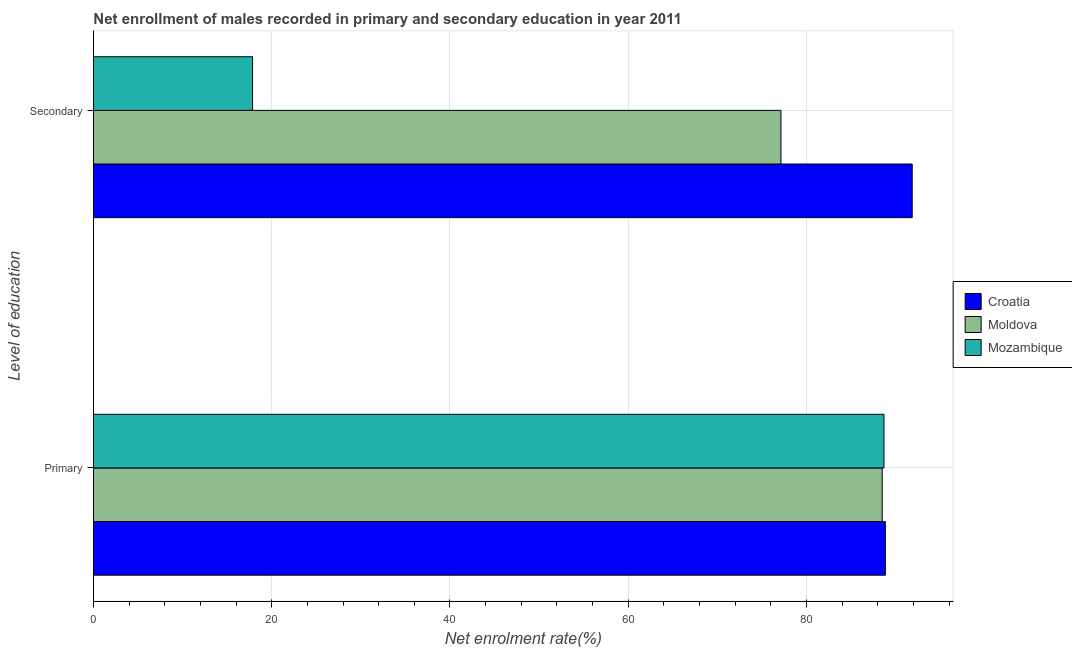How many bars are there on the 2nd tick from the bottom?
Ensure brevity in your answer.  3. What is the label of the 2nd group of bars from the top?
Your answer should be very brief. Primary. What is the enrollment rate in primary education in Moldova?
Make the answer very short. 88.49. Across all countries, what is the maximum enrollment rate in secondary education?
Make the answer very short. 91.86. Across all countries, what is the minimum enrollment rate in primary education?
Offer a terse response. 88.49. In which country was the enrollment rate in secondary education maximum?
Provide a succinct answer. Croatia. In which country was the enrollment rate in secondary education minimum?
Keep it short and to the point. Mozambique. What is the total enrollment rate in primary education in the graph?
Offer a terse response. 266.03. What is the difference between the enrollment rate in secondary education in Moldova and that in Croatia?
Provide a short and direct response. -14.73. What is the difference between the enrollment rate in secondary education in Croatia and the enrollment rate in primary education in Mozambique?
Provide a short and direct response. 3.17. What is the average enrollment rate in primary education per country?
Provide a succinct answer. 88.68. What is the difference between the enrollment rate in secondary education and enrollment rate in primary education in Moldova?
Provide a succinct answer. -11.36. In how many countries, is the enrollment rate in primary education greater than 68 %?
Your response must be concise. 3. What is the ratio of the enrollment rate in primary education in Moldova to that in Croatia?
Ensure brevity in your answer.  1. In how many countries, is the enrollment rate in secondary education greater than the average enrollment rate in secondary education taken over all countries?
Offer a very short reply. 2. What does the 3rd bar from the top in Secondary represents?
Offer a terse response. Croatia. What does the 1st bar from the bottom in Primary represents?
Ensure brevity in your answer.  Croatia. How many countries are there in the graph?
Give a very brief answer. 3. What is the difference between two consecutive major ticks on the X-axis?
Your answer should be very brief. 20. Are the values on the major ticks of X-axis written in scientific E-notation?
Keep it short and to the point. No. Does the graph contain any zero values?
Offer a terse response. No. Does the graph contain grids?
Give a very brief answer. Yes. Where does the legend appear in the graph?
Your answer should be compact. Center right. What is the title of the graph?
Provide a succinct answer. Net enrollment of males recorded in primary and secondary education in year 2011. What is the label or title of the X-axis?
Provide a short and direct response. Net enrolment rate(%). What is the label or title of the Y-axis?
Give a very brief answer. Level of education. What is the Net enrolment rate(%) in Croatia in Primary?
Offer a very short reply. 88.85. What is the Net enrolment rate(%) of Moldova in Primary?
Offer a very short reply. 88.49. What is the Net enrolment rate(%) in Mozambique in Primary?
Offer a very short reply. 88.69. What is the Net enrolment rate(%) of Croatia in Secondary?
Your answer should be very brief. 91.86. What is the Net enrolment rate(%) of Moldova in Secondary?
Your answer should be compact. 77.13. What is the Net enrolment rate(%) in Mozambique in Secondary?
Give a very brief answer. 17.85. Across all Level of education, what is the maximum Net enrolment rate(%) of Croatia?
Make the answer very short. 91.86. Across all Level of education, what is the maximum Net enrolment rate(%) in Moldova?
Make the answer very short. 88.49. Across all Level of education, what is the maximum Net enrolment rate(%) in Mozambique?
Offer a terse response. 88.69. Across all Level of education, what is the minimum Net enrolment rate(%) of Croatia?
Make the answer very short. 88.85. Across all Level of education, what is the minimum Net enrolment rate(%) in Moldova?
Your answer should be compact. 77.13. Across all Level of education, what is the minimum Net enrolment rate(%) in Mozambique?
Your response must be concise. 17.85. What is the total Net enrolment rate(%) in Croatia in the graph?
Your response must be concise. 180.71. What is the total Net enrolment rate(%) in Moldova in the graph?
Make the answer very short. 165.63. What is the total Net enrolment rate(%) of Mozambique in the graph?
Your answer should be very brief. 106.54. What is the difference between the Net enrolment rate(%) in Croatia in Primary and that in Secondary?
Provide a short and direct response. -3.01. What is the difference between the Net enrolment rate(%) of Moldova in Primary and that in Secondary?
Your answer should be very brief. 11.36. What is the difference between the Net enrolment rate(%) in Mozambique in Primary and that in Secondary?
Keep it short and to the point. 70.84. What is the difference between the Net enrolment rate(%) in Croatia in Primary and the Net enrolment rate(%) in Moldova in Secondary?
Offer a terse response. 11.71. What is the difference between the Net enrolment rate(%) of Croatia in Primary and the Net enrolment rate(%) of Mozambique in Secondary?
Offer a very short reply. 71. What is the difference between the Net enrolment rate(%) in Moldova in Primary and the Net enrolment rate(%) in Mozambique in Secondary?
Offer a very short reply. 70.64. What is the average Net enrolment rate(%) of Croatia per Level of education?
Your answer should be very brief. 90.35. What is the average Net enrolment rate(%) of Moldova per Level of education?
Ensure brevity in your answer.  82.81. What is the average Net enrolment rate(%) of Mozambique per Level of education?
Make the answer very short. 53.27. What is the difference between the Net enrolment rate(%) of Croatia and Net enrolment rate(%) of Moldova in Primary?
Make the answer very short. 0.35. What is the difference between the Net enrolment rate(%) of Croatia and Net enrolment rate(%) of Mozambique in Primary?
Your answer should be compact. 0.16. What is the difference between the Net enrolment rate(%) in Moldova and Net enrolment rate(%) in Mozambique in Primary?
Provide a succinct answer. -0.2. What is the difference between the Net enrolment rate(%) of Croatia and Net enrolment rate(%) of Moldova in Secondary?
Give a very brief answer. 14.73. What is the difference between the Net enrolment rate(%) in Croatia and Net enrolment rate(%) in Mozambique in Secondary?
Give a very brief answer. 74.01. What is the difference between the Net enrolment rate(%) in Moldova and Net enrolment rate(%) in Mozambique in Secondary?
Your answer should be very brief. 59.28. What is the ratio of the Net enrolment rate(%) of Croatia in Primary to that in Secondary?
Your answer should be very brief. 0.97. What is the ratio of the Net enrolment rate(%) of Moldova in Primary to that in Secondary?
Keep it short and to the point. 1.15. What is the ratio of the Net enrolment rate(%) of Mozambique in Primary to that in Secondary?
Offer a terse response. 4.97. What is the difference between the highest and the second highest Net enrolment rate(%) in Croatia?
Keep it short and to the point. 3.01. What is the difference between the highest and the second highest Net enrolment rate(%) in Moldova?
Ensure brevity in your answer.  11.36. What is the difference between the highest and the second highest Net enrolment rate(%) in Mozambique?
Your response must be concise. 70.84. What is the difference between the highest and the lowest Net enrolment rate(%) of Croatia?
Offer a very short reply. 3.01. What is the difference between the highest and the lowest Net enrolment rate(%) of Moldova?
Ensure brevity in your answer.  11.36. What is the difference between the highest and the lowest Net enrolment rate(%) in Mozambique?
Offer a terse response. 70.84. 